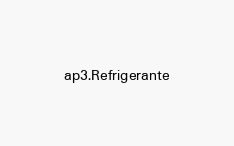<code> <loc_0><loc_0><loc_500><loc_500><_Rust_>ap3.Refrigerante
</code> 